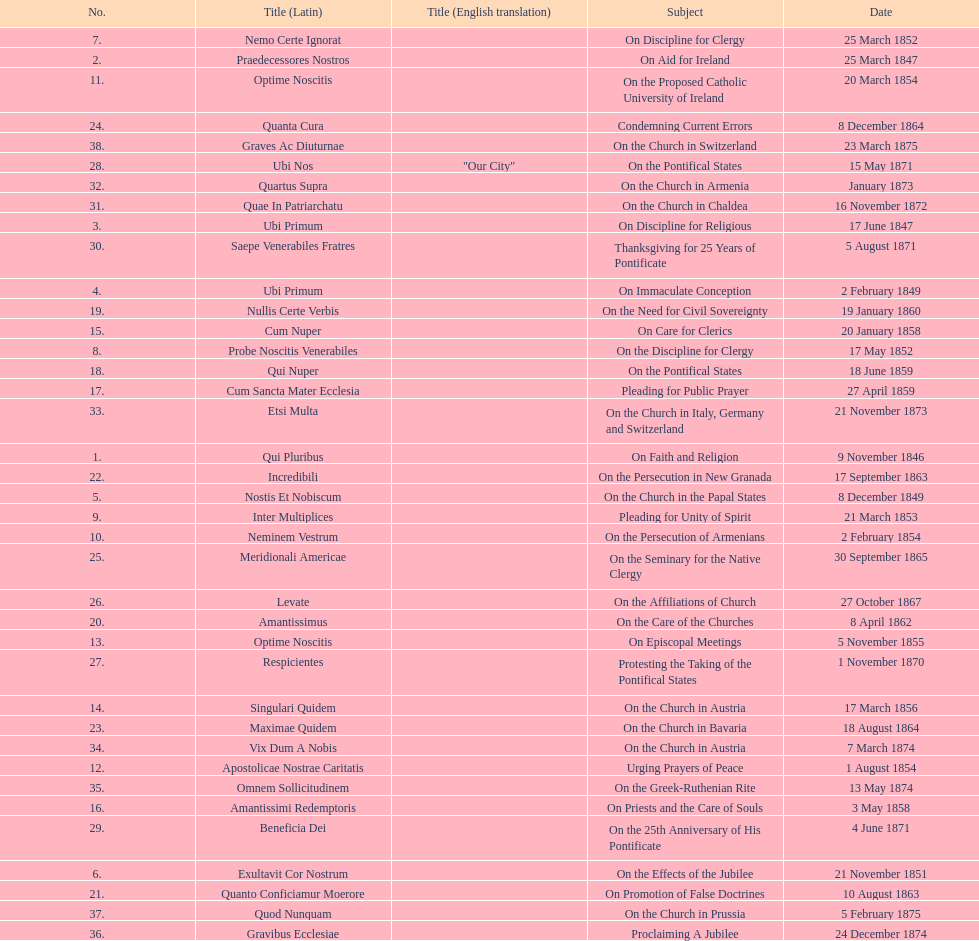In the first 10 years of his reign, how many encyclicals did pope pius ix issue? 14. 